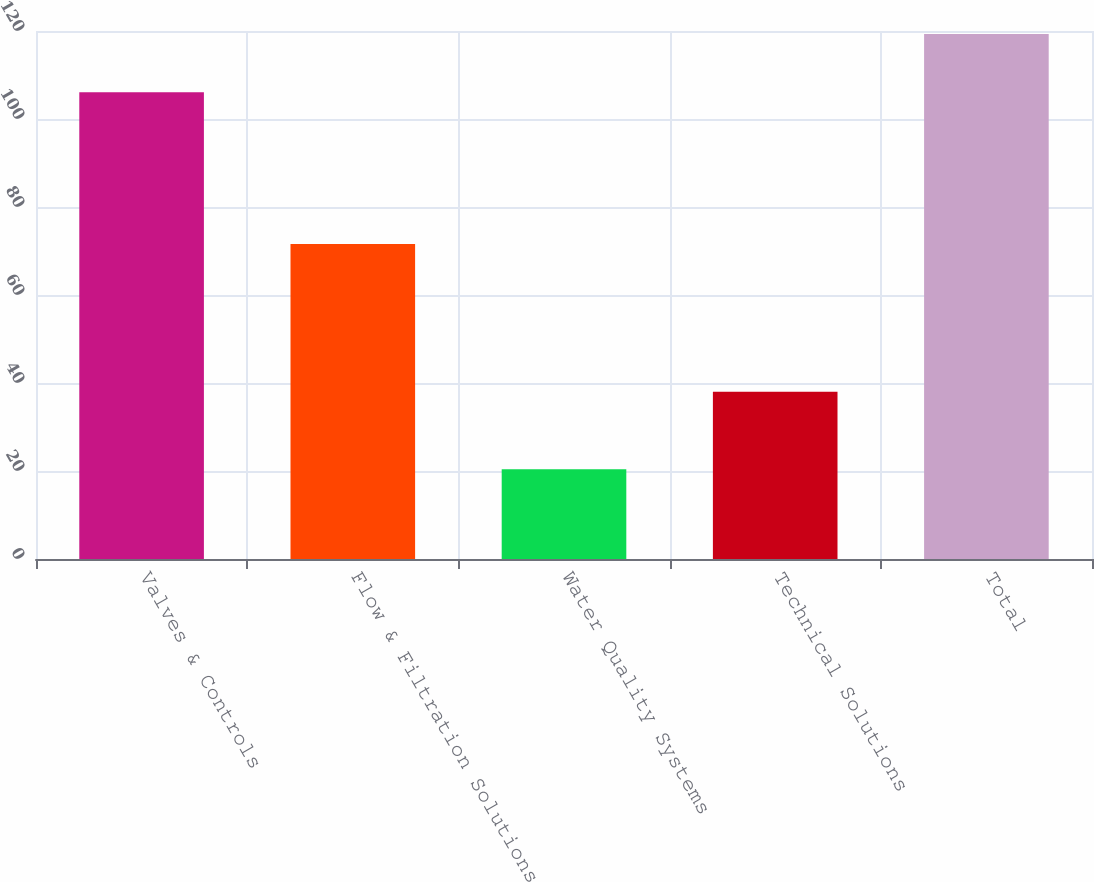Convert chart. <chart><loc_0><loc_0><loc_500><loc_500><bar_chart><fcel>Valves & Controls<fcel>Flow & Filtration Solutions<fcel>Water Quality Systems<fcel>Technical Solutions<fcel>Total<nl><fcel>106.1<fcel>71.6<fcel>20.4<fcel>38<fcel>119.3<nl></chart> 